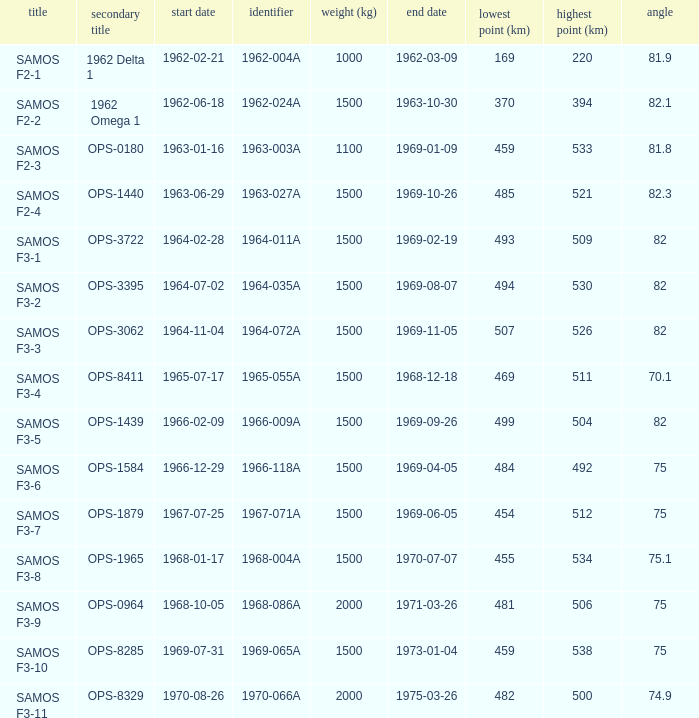Parse the full table. {'header': ['title', 'secondary title', 'start date', 'identifier', 'weight (kg)', 'end date', 'lowest point (km)', 'highest point (km)', 'angle'], 'rows': [['SAMOS F2-1', '1962 Delta 1', '1962-02-21', '1962-004A', '1000', '1962-03-09', '169', '220', '81.9'], ['SAMOS F2-2', '1962 Omega 1', '1962-06-18', '1962-024A', '1500', '1963-10-30', '370', '394', '82.1'], ['SAMOS F2-3', 'OPS-0180', '1963-01-16', '1963-003A', '1100', '1969-01-09', '459', '533', '81.8'], ['SAMOS F2-4', 'OPS-1440', '1963-06-29', '1963-027A', '1500', '1969-10-26', '485', '521', '82.3'], ['SAMOS F3-1', 'OPS-3722', '1964-02-28', '1964-011A', '1500', '1969-02-19', '493', '509', '82'], ['SAMOS F3-2', 'OPS-3395', '1964-07-02', '1964-035A', '1500', '1969-08-07', '494', '530', '82'], ['SAMOS F3-3', 'OPS-3062', '1964-11-04', '1964-072A', '1500', '1969-11-05', '507', '526', '82'], ['SAMOS F3-4', 'OPS-8411', '1965-07-17', '1965-055A', '1500', '1968-12-18', '469', '511', '70.1'], ['SAMOS F3-5', 'OPS-1439', '1966-02-09', '1966-009A', '1500', '1969-09-26', '499', '504', '82'], ['SAMOS F3-6', 'OPS-1584', '1966-12-29', '1966-118A', '1500', '1969-04-05', '484', '492', '75'], ['SAMOS F3-7', 'OPS-1879', '1967-07-25', '1967-071A', '1500', '1969-06-05', '454', '512', '75'], ['SAMOS F3-8', 'OPS-1965', '1968-01-17', '1968-004A', '1500', '1970-07-07', '455', '534', '75.1'], ['SAMOS F3-9', 'OPS-0964', '1968-10-05', '1968-086A', '2000', '1971-03-26', '481', '506', '75'], ['SAMOS F3-10', 'OPS-8285', '1969-07-31', '1969-065A', '1500', '1973-01-04', '459', '538', '75'], ['SAMOS F3-11', 'OPS-8329', '1970-08-26', '1970-066A', '2000', '1975-03-26', '482', '500', '74.9']]} What was the maximum perigee on 1969-01-09? 459.0. 